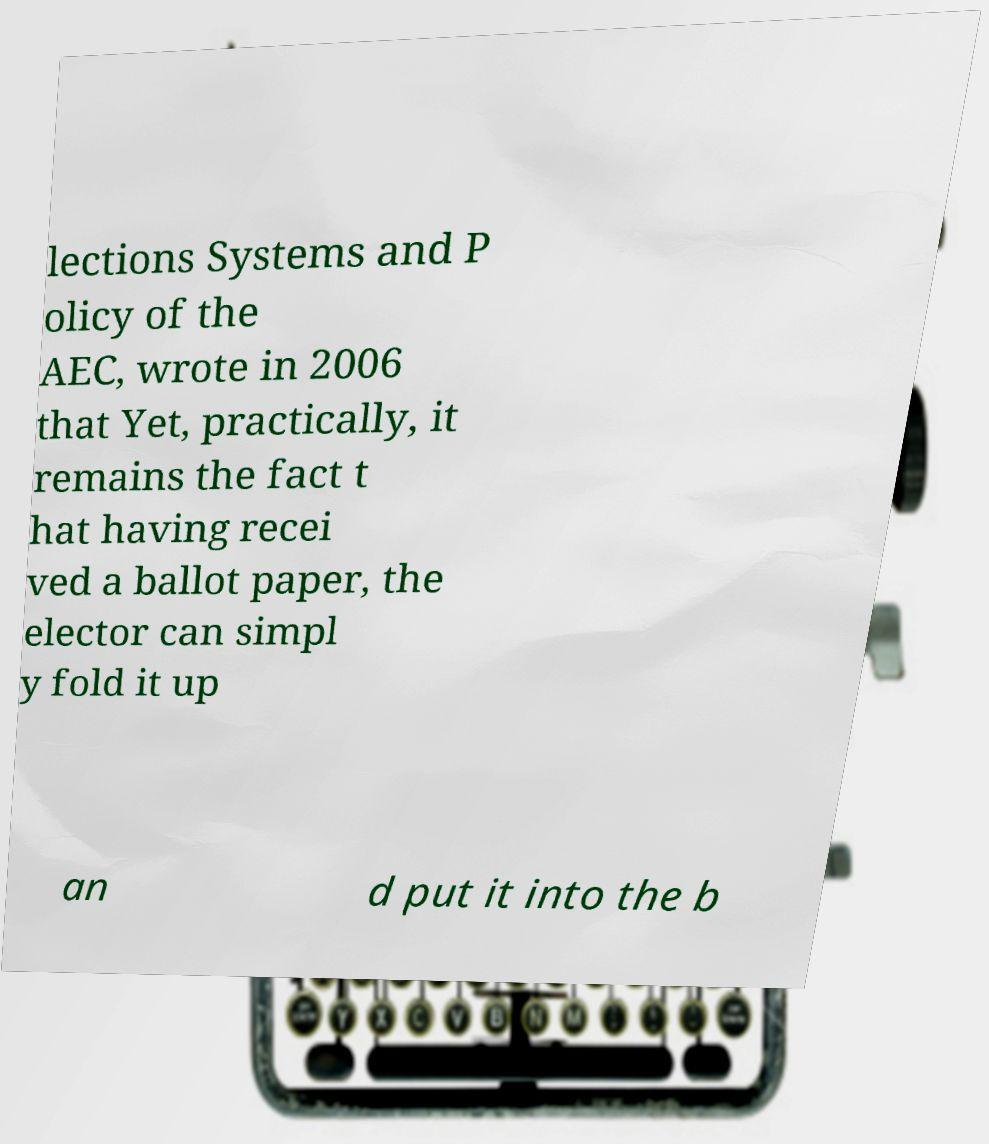I need the written content from this picture converted into text. Can you do that? lections Systems and P olicy of the AEC, wrote in 2006 that Yet, practically, it remains the fact t hat having recei ved a ballot paper, the elector can simpl y fold it up an d put it into the b 